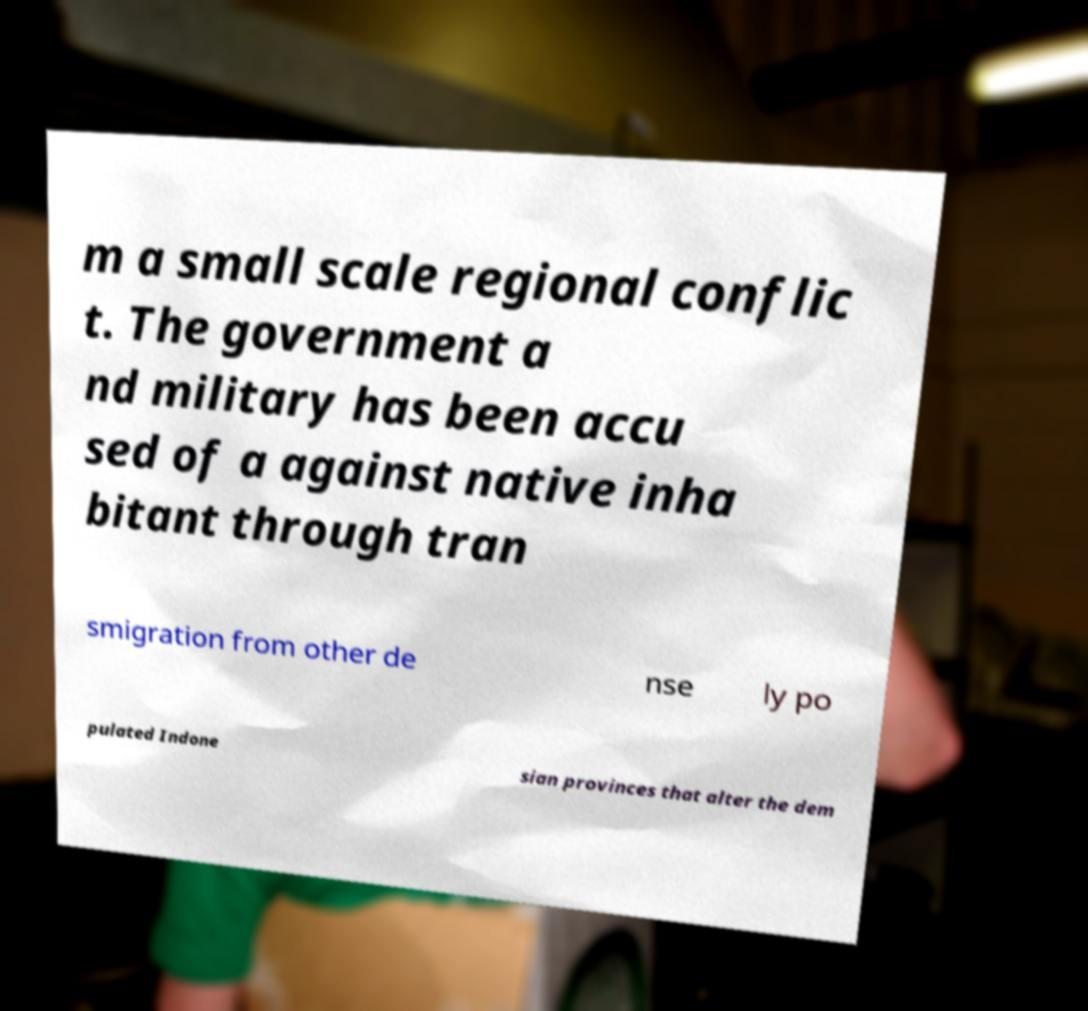Please identify and transcribe the text found in this image. m a small scale regional conflic t. The government a nd military has been accu sed of a against native inha bitant through tran smigration from other de nse ly po pulated Indone sian provinces that alter the dem 